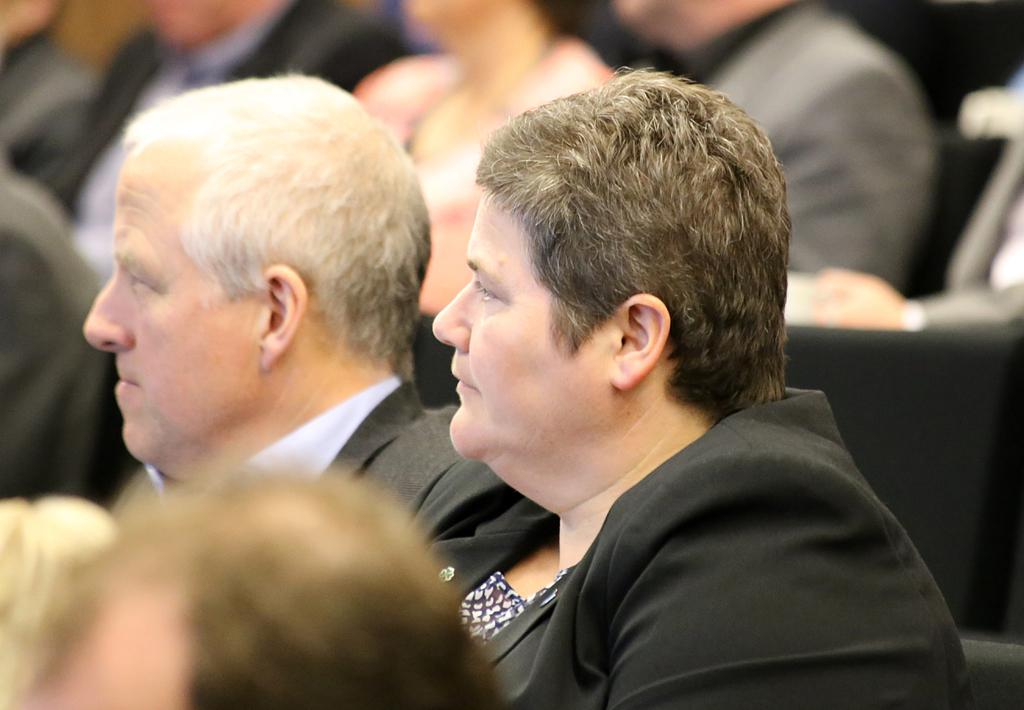What is the main subject of the image? There is a person in the image. What is the person doing in the image? The person is sitting on chairs. How many beds are visible in the image? There are no beds visible in the image; it only shows a person sitting on chairs. What type of cast is on the person's arm in the image? There is no cast present on the person's arm in the image; the person is simply sitting on chairs. 